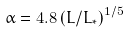<formula> <loc_0><loc_0><loc_500><loc_500>\alpha = 4 . 8 \left ( L / L _ { \ast } \right ) ^ { 1 / 5 }</formula> 